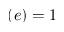Convert formula to latex. <formula><loc_0><loc_0><loc_500><loc_500>( e ) = 1</formula> 